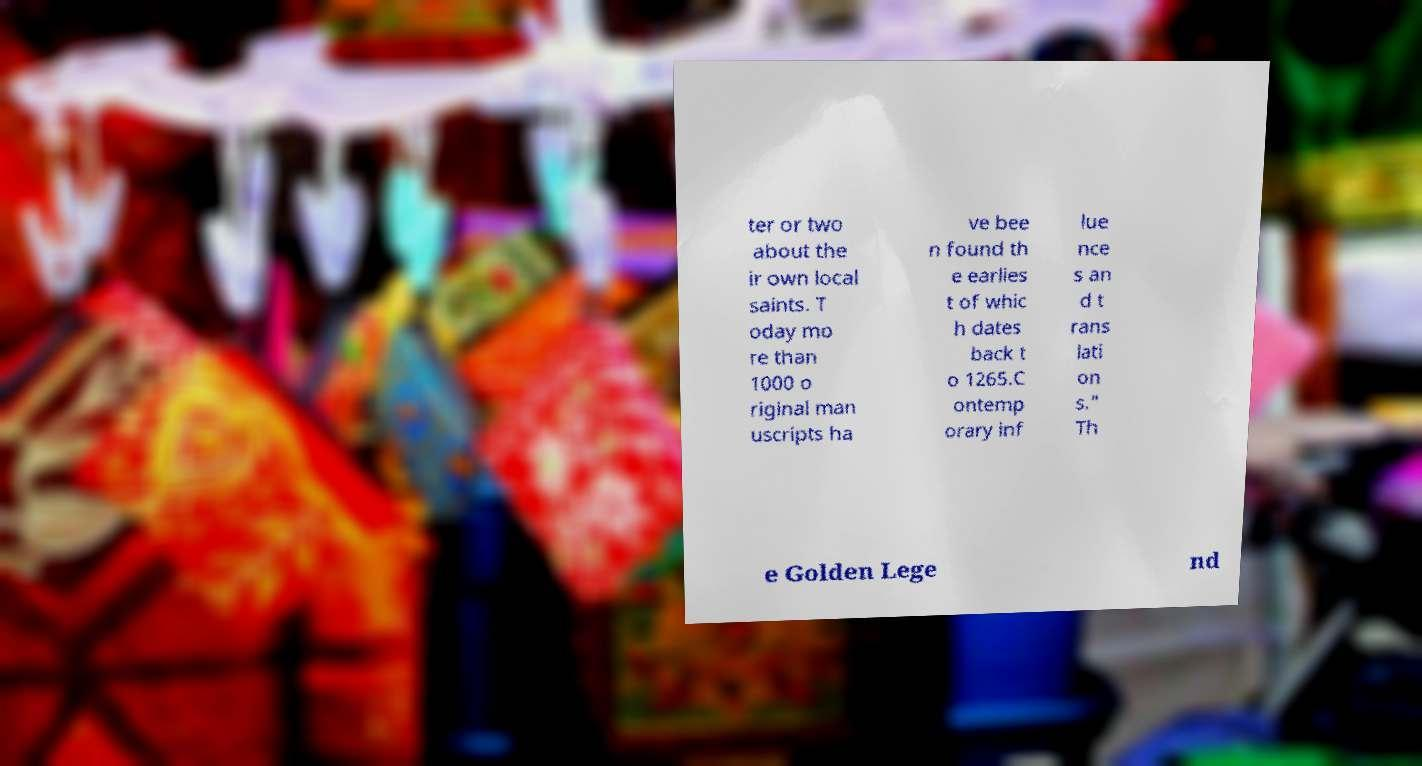What messages or text are displayed in this image? I need them in a readable, typed format. ter or two about the ir own local saints. T oday mo re than 1000 o riginal man uscripts ha ve bee n found th e earlies t of whic h dates back t o 1265.C ontemp orary inf lue nce s an d t rans lati on s." Th e Golden Lege nd 